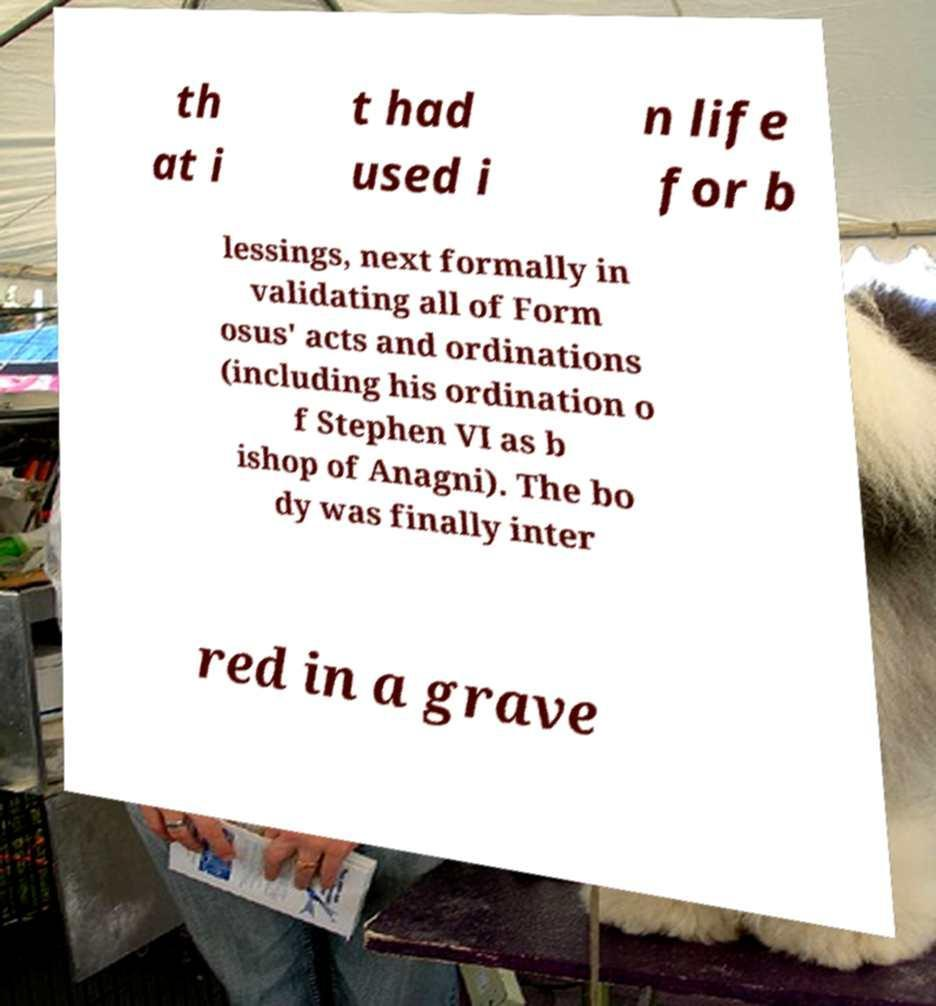Could you extract and type out the text from this image? th at i t had used i n life for b lessings, next formally in validating all of Form osus' acts and ordinations (including his ordination o f Stephen VI as b ishop of Anagni). The bo dy was finally inter red in a grave 